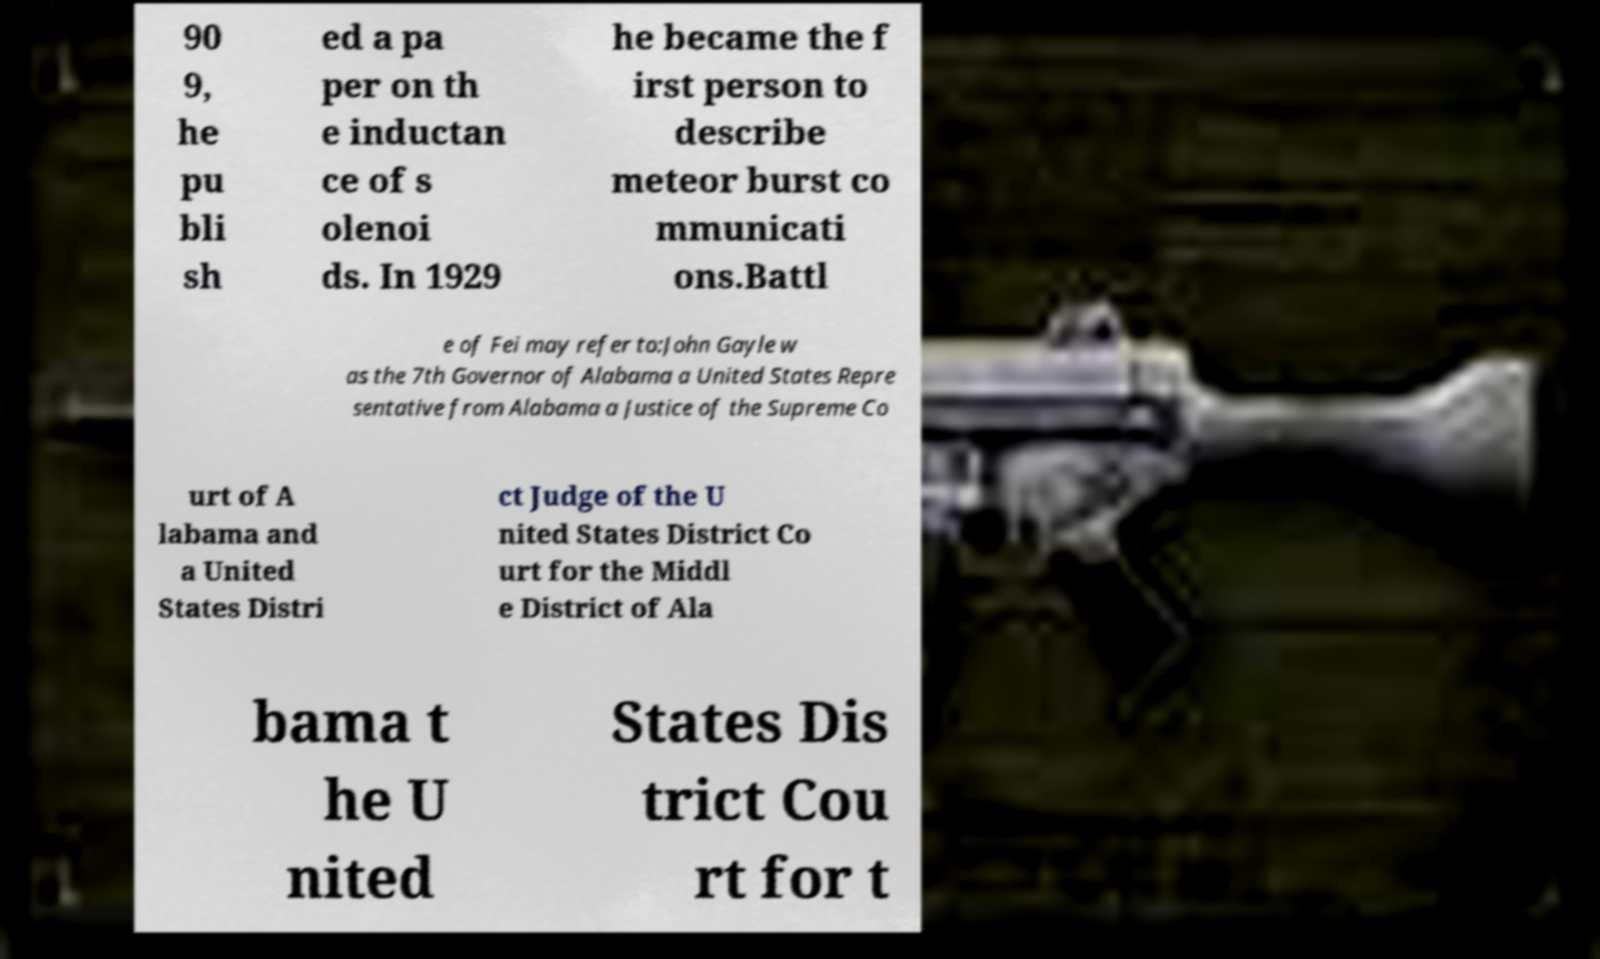For documentation purposes, I need the text within this image transcribed. Could you provide that? 90 9, he pu bli sh ed a pa per on th e inductan ce of s olenoi ds. In 1929 he became the f irst person to describe meteor burst co mmunicati ons.Battl e of Fei may refer to:John Gayle w as the 7th Governor of Alabama a United States Repre sentative from Alabama a Justice of the Supreme Co urt of A labama and a United States Distri ct Judge of the U nited States District Co urt for the Middl e District of Ala bama t he U nited States Dis trict Cou rt for t 